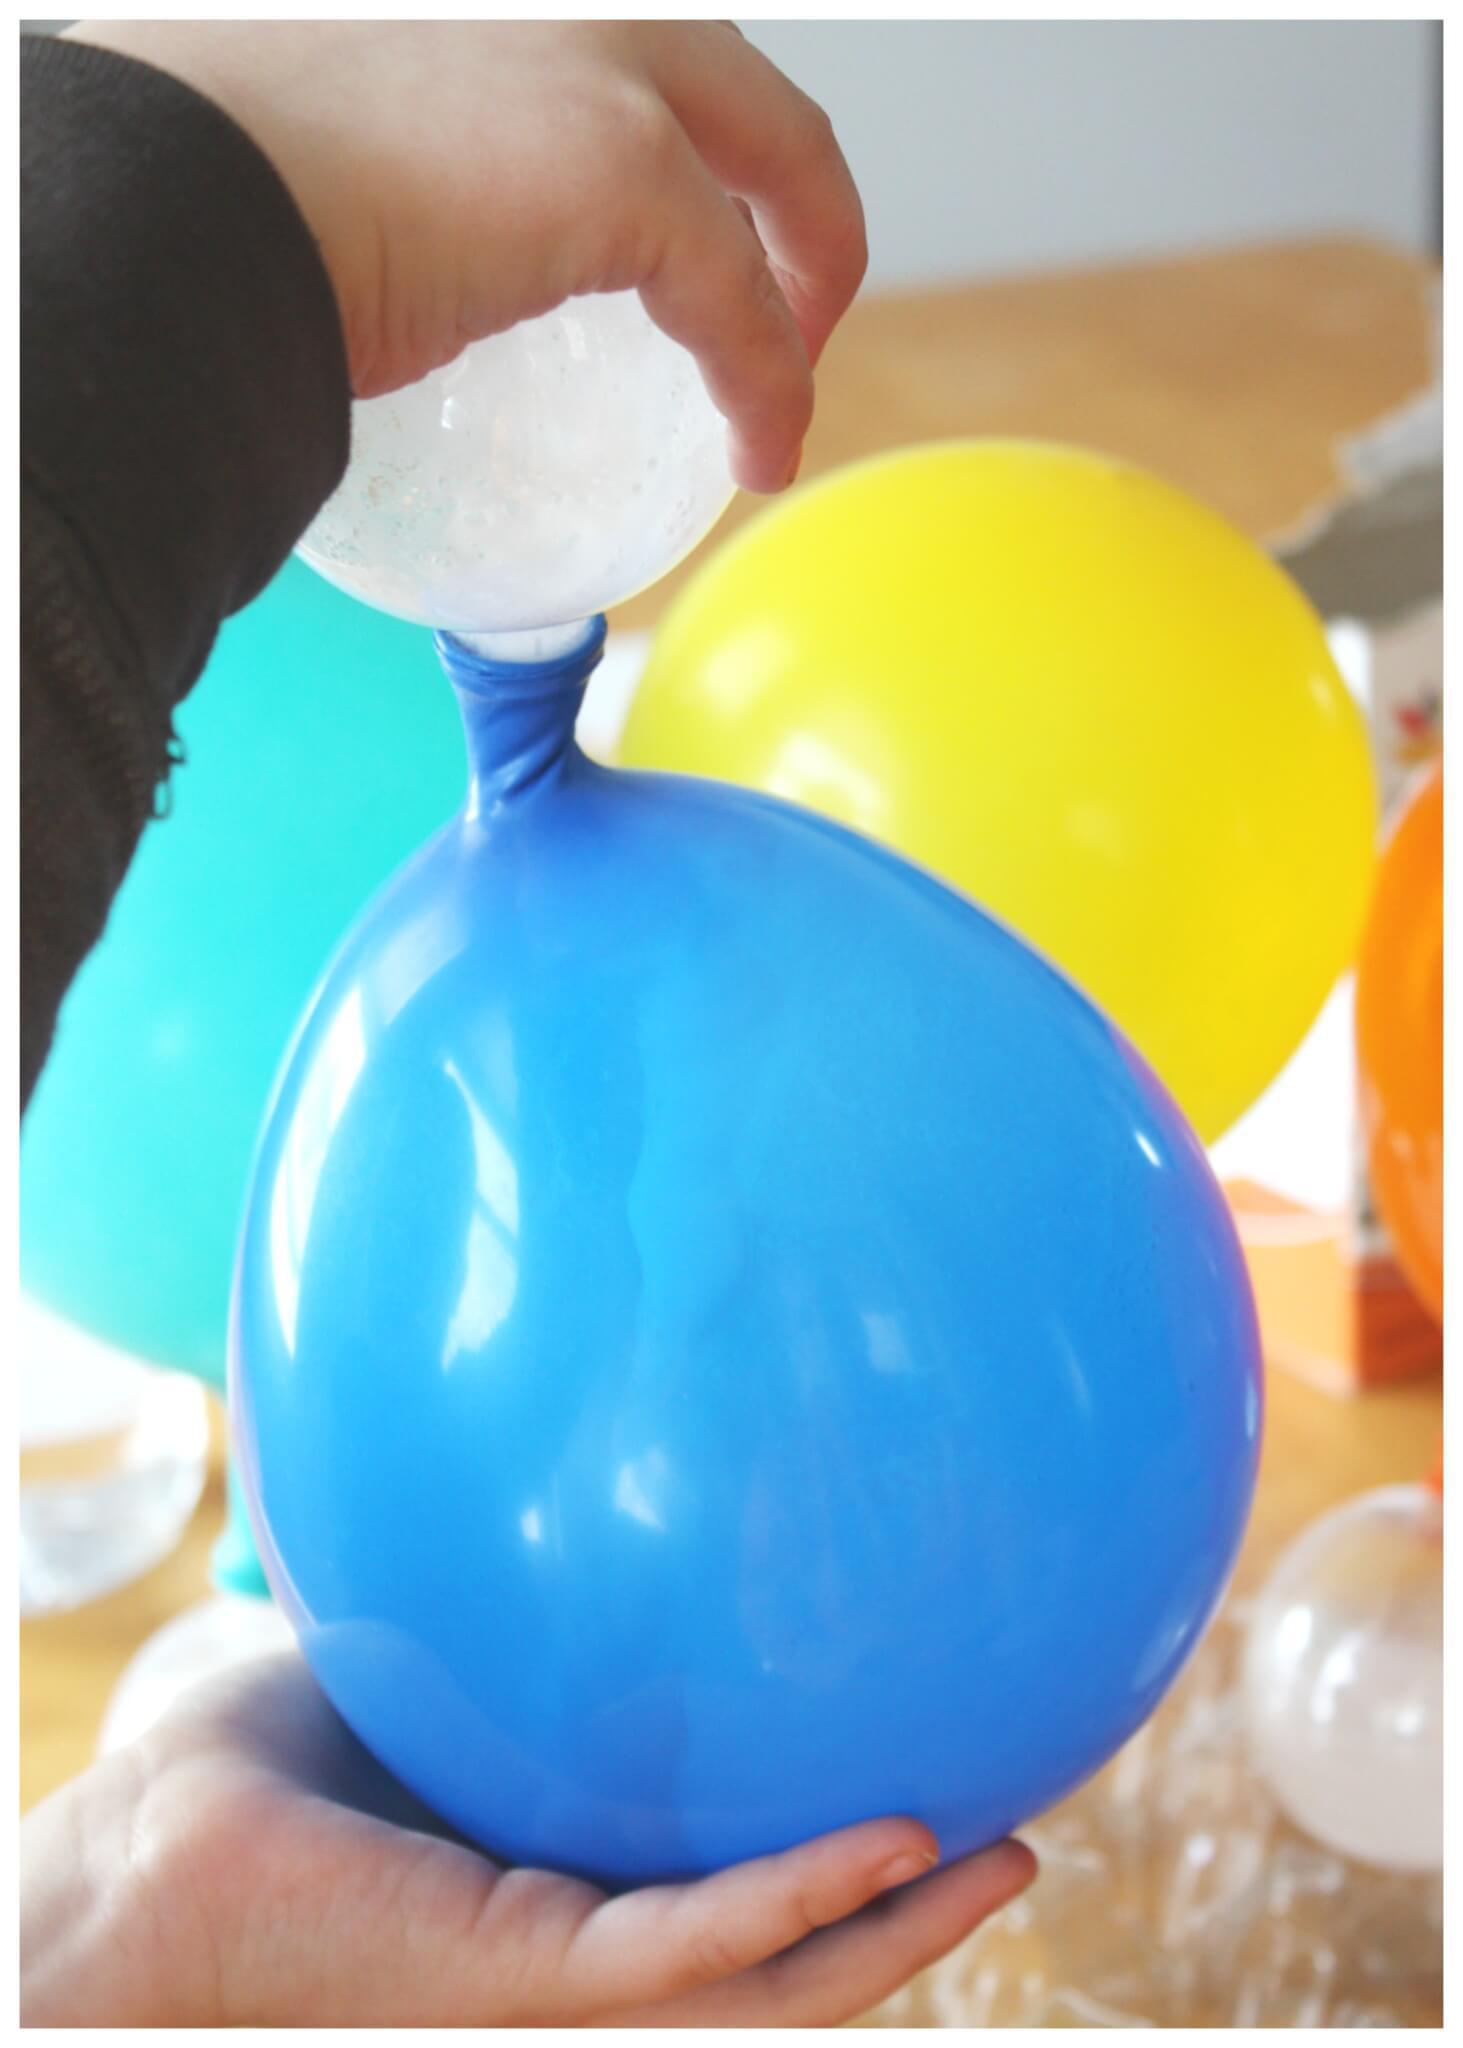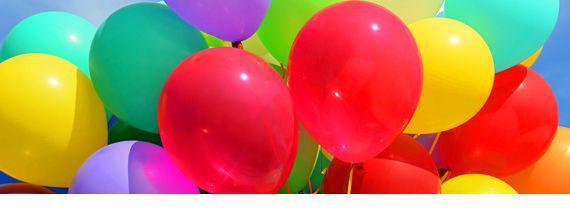The first image is the image on the left, the second image is the image on the right. Analyze the images presented: Is the assertion "One person whose face cannot be seen is holding at least one balloon." valid? Answer yes or no. Yes. 